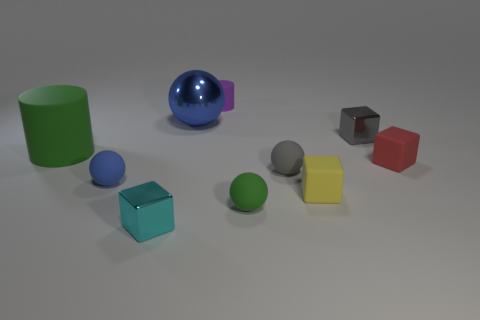There is a large object that is the same material as the small green thing; what color is it?
Offer a terse response. Green. What color is the sphere that is behind the gray object that is in front of the tiny metallic block that is behind the big rubber thing?
Your answer should be compact. Blue. How many cubes are either large green things or small purple matte things?
Your response must be concise. 0. There is another small sphere that is the same color as the metallic sphere; what is it made of?
Your response must be concise. Rubber. There is a metallic ball; is it the same color as the tiny matte object on the left side of the blue shiny sphere?
Provide a short and direct response. Yes. What color is the big rubber object?
Give a very brief answer. Green. How many objects are tiny rubber cylinders or small cyan metal things?
Ensure brevity in your answer.  2. There is a green thing that is the same size as the gray matte ball; what is it made of?
Provide a succinct answer. Rubber. What size is the metallic thing right of the big blue metallic sphere?
Keep it short and to the point. Small. What material is the large blue thing?
Make the answer very short. Metal. 